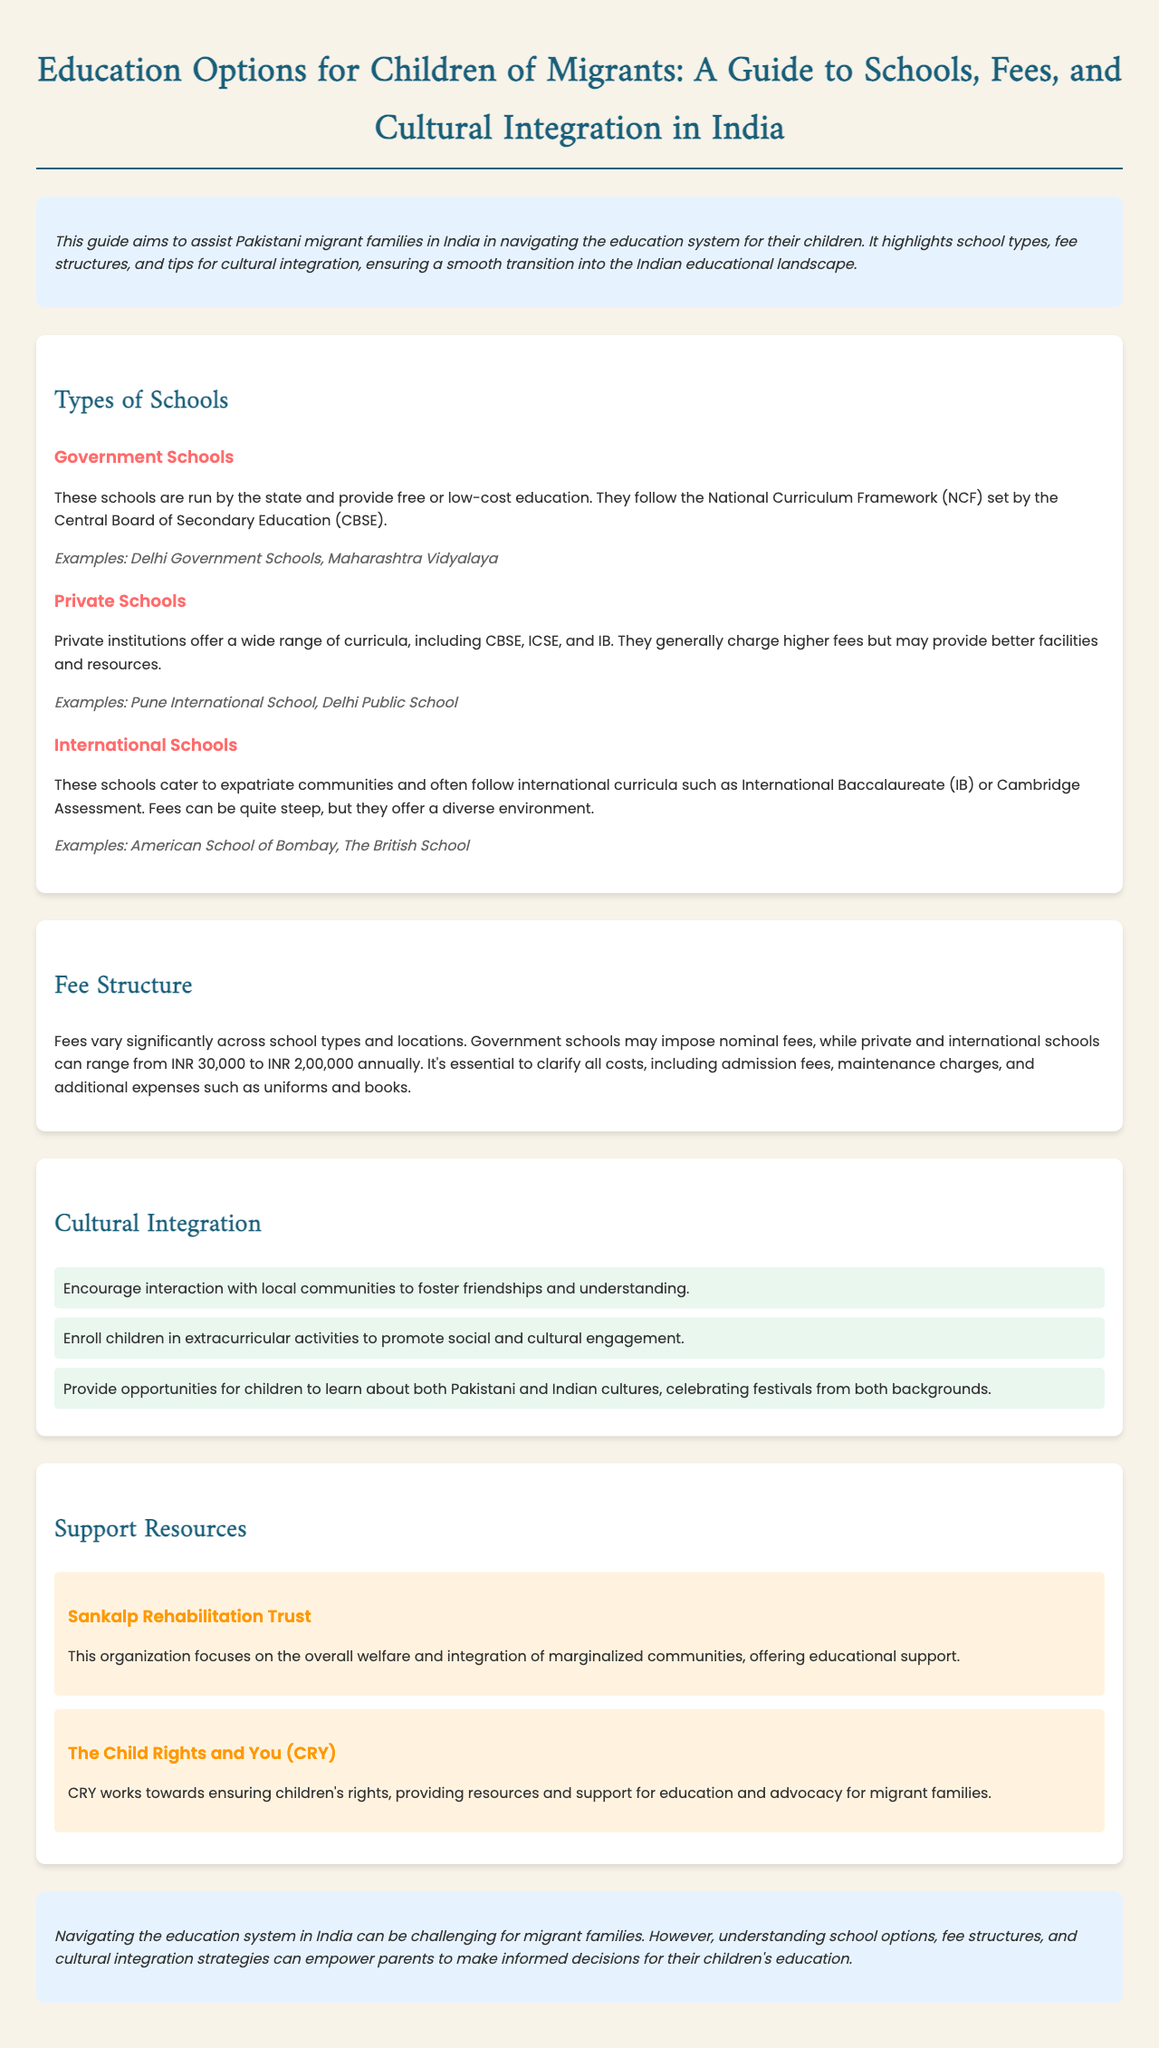What is the title of the guide? The title summarizes the document's purpose, focusing on education options for migrant children.
Answer: Education Options for Children of Migrants: A Guide to Schools, Fees, and Cultural Integration in India How many types of schools are mentioned? The document lists three distinct types of schools available for migrant children.
Answer: 3 What is the range of fees for private and international schools? The fee structure provided indicates a significant range for these school types.
Answer: INR 30,000 to INR 2,00,000 Name one example of a government school. The document provides specific examples to illustrate different school types.
Answer: Delhi Government Schools What is one tip for cultural integration? Suggestions for cultural integration are provided to assist families in their transition.
Answer: Encourage interaction with local communities Which organization focuses on the welfare and integration of marginalized communities? The document lists support resources for parents seeking help for their children's education.
Answer: Sankalp Rehabilitation Trust What curriculum do government schools follow? This is a specific detail about the education framework government schools adhere to.
Answer: National Curriculum Framework (NCF) What color is the background used in the conclusion section? The color scheme of the sections is indicated to enhance visual appeal.
Answer: Light blue 